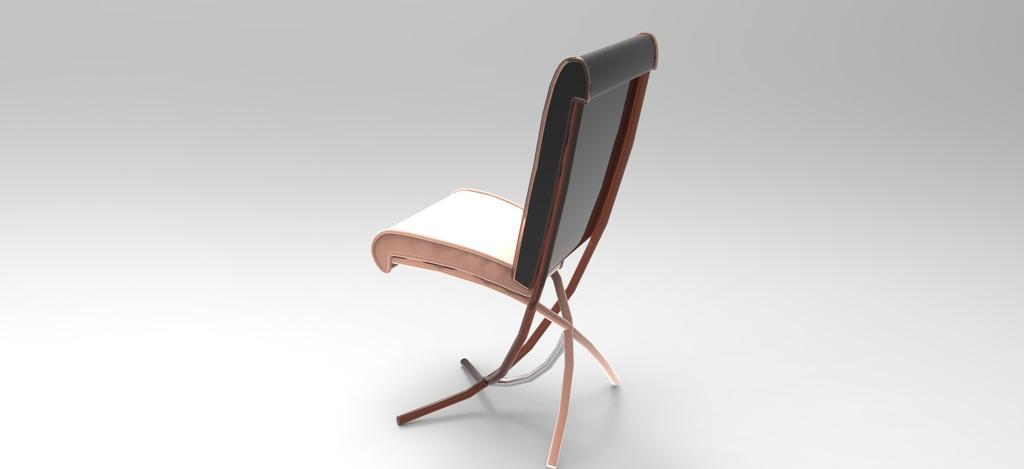Could you give a brief overview of what you see in this image? In this image we can see a chair. 